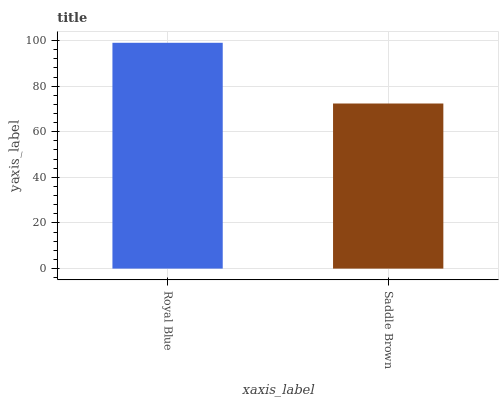Is Saddle Brown the minimum?
Answer yes or no. Yes. Is Royal Blue the maximum?
Answer yes or no. Yes. Is Saddle Brown the maximum?
Answer yes or no. No. Is Royal Blue greater than Saddle Brown?
Answer yes or no. Yes. Is Saddle Brown less than Royal Blue?
Answer yes or no. Yes. Is Saddle Brown greater than Royal Blue?
Answer yes or no. No. Is Royal Blue less than Saddle Brown?
Answer yes or no. No. Is Royal Blue the high median?
Answer yes or no. Yes. Is Saddle Brown the low median?
Answer yes or no. Yes. Is Saddle Brown the high median?
Answer yes or no. No. Is Royal Blue the low median?
Answer yes or no. No. 